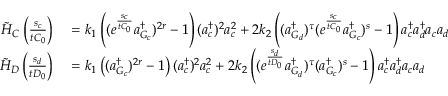Convert formula to latex. <formula><loc_0><loc_0><loc_500><loc_500>\begin{array} { r l } { \tilde { H } _ { C } \left ( \frac { s _ { c } } { t C _ { 0 } } \right ) } & = k _ { 1 } \left ( ( e ^ { \frac { s _ { c } } { t C _ { 0 } } } a _ { G _ { c } } ^ { \dagger } ) ^ { 2 r } - 1 \right ) ( a _ { c } ^ { \dagger } ) ^ { 2 } a _ { c } ^ { 2 } + 2 k _ { 2 } \left ( ( a _ { G _ { d } } ^ { \dagger } ) ^ { \tau } ( e ^ { \frac { s _ { c } } { t C _ { 0 } } } a _ { G _ { c } } ^ { \dagger } ) ^ { s } - 1 \right ) a _ { c } ^ { \dagger } a _ { d } ^ { \dagger } a _ { c } a _ { d } } \\ { \tilde { H } _ { D } \left ( \frac { s _ { d } } { t D _ { 0 } } \right ) } & = k _ { 1 } \left ( ( a _ { G _ { c } } ^ { \dagger } ) ^ { 2 r } - 1 \right ) ( a _ { c } ^ { \dagger } ) ^ { 2 } a _ { c } ^ { 2 } + 2 k _ { 2 } \left ( ( e ^ { \frac { s _ { d } } { t D _ { 0 } } } a _ { G _ { d } } ^ { \dagger } ) ^ { \tau } ( a _ { G _ { c } } ^ { \dagger } ) ^ { s } - 1 \right ) a _ { c } ^ { \dagger } a _ { d } ^ { \dagger } a _ { c } a _ { d } } \end{array}</formula> 